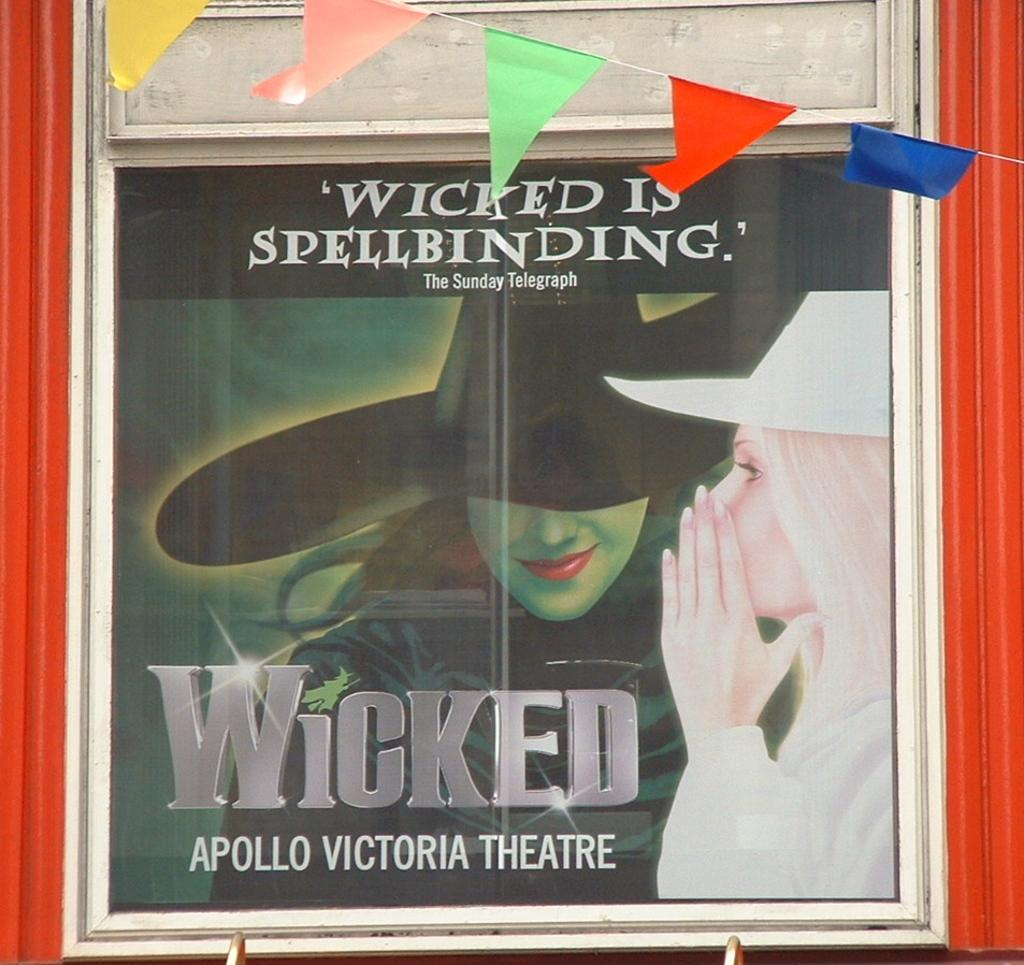<image>
Share a concise interpretation of the image provided. a Wicked advertisement for the Apollo Victoria Theatre 